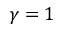<formula> <loc_0><loc_0><loc_500><loc_500>\gamma = 1</formula> 